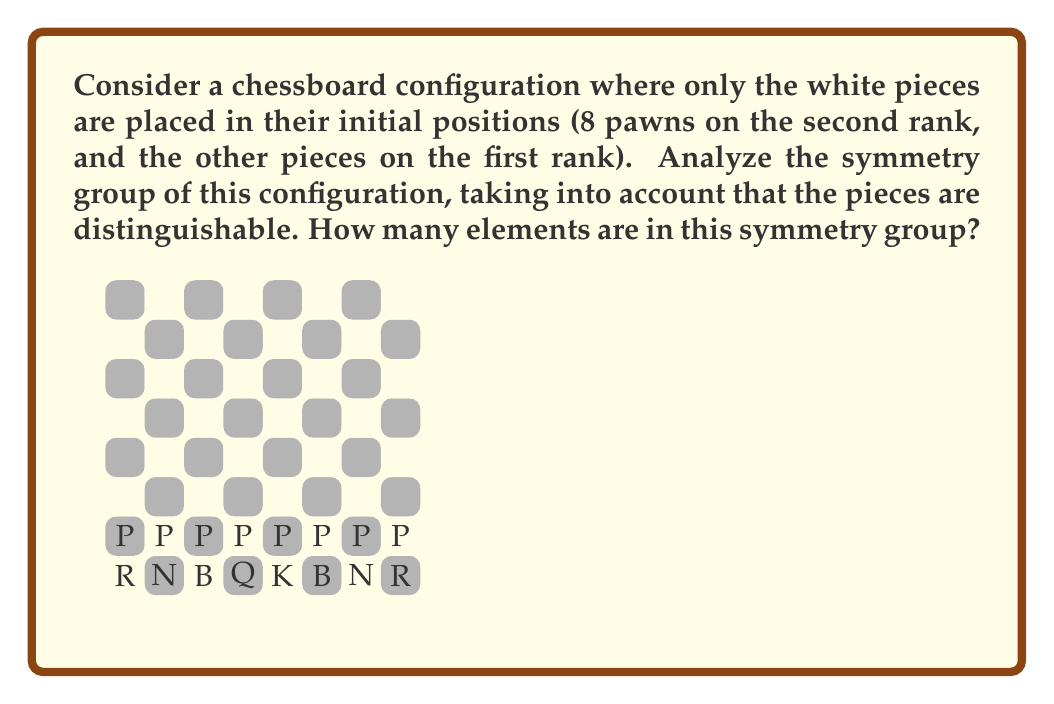Provide a solution to this math problem. To analyze the symmetry group of this chessboard configuration, we need to consider the possible transformations that leave the configuration unchanged:

1) First, note that rotation and reflection symmetries of the entire board are not possible due to the distinct pieces.

2) The only possible symmetry is the horizontal reflection across the central vertical line of the board.

3) Let's examine how this reflection affects each piece:
   - The King (K) and Queen (Q) swap positions
   - The Bishops (B) remain in their positions
   - The Knights (N) swap positions
   - The Rooks (R) swap positions
   - The Pawns (P) each swap with their counterpart on the other side

4) This reflection is its own inverse, meaning applying it twice returns the board to its original state.

5) Therefore, we have two elements in our symmetry group:
   - The identity transformation (leaving the board unchanged)
   - The horizontal reflection

6) Mathematically, this group is isomorphic to the cyclic group of order 2, denoted as $C_2$ or $\mathbb{Z}_2$.

7) The order of this group, which is the number of elements, is 2.
Answer: 2 